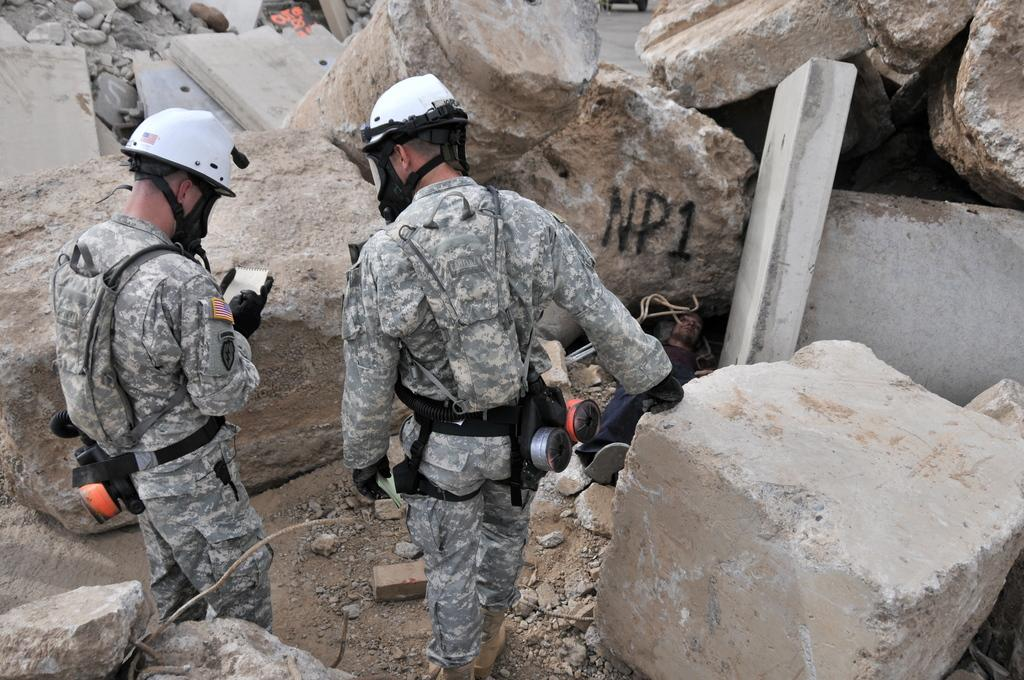How many people are in the foreground of the image? There are two persons in the foreground of the image. What are the persons doing in the image? The persons are standing in the image. What are the persons wearing on their heads? The persons are wearing helmets in the image. What can be seen in the background of the image? There are rocks in the background of the image. What type of door can be seen in the image? There is no door present in the image. How does the throat of the person on the left feel in the image? There is no information about the person's throat in the image. 